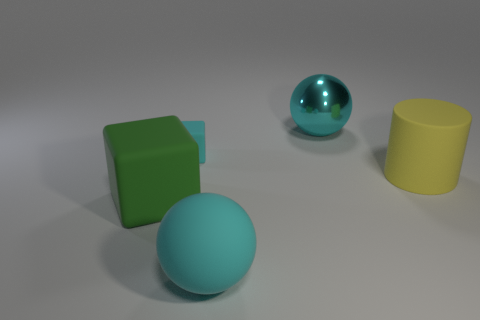There is a large green block; are there any large green things right of it?
Give a very brief answer. No. Do the sphere that is in front of the large green matte cube and the large object that is behind the large yellow rubber cylinder have the same material?
Ensure brevity in your answer.  No. Is the number of small cyan matte cubes that are in front of the green rubber cube less than the number of small blocks?
Your response must be concise. Yes. What is the color of the large object that is on the right side of the cyan shiny sphere?
Your response must be concise. Yellow. There is a big cyan object to the left of the cyan ball that is behind the cyan block; what is its material?
Make the answer very short. Rubber. Are there any cyan balls that have the same size as the rubber cylinder?
Your answer should be very brief. Yes. How many objects are either large rubber objects to the left of the small matte cube or objects right of the green cube?
Your answer should be very brief. 5. Does the matte block behind the big yellow cylinder have the same size as the matte object that is on the right side of the large cyan rubber sphere?
Provide a succinct answer. No. There is a large thing that is on the right side of the big shiny ball; are there any big cylinders right of it?
Offer a terse response. No. What number of yellow matte objects are to the right of the large matte ball?
Provide a succinct answer. 1. 